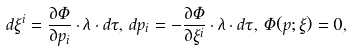<formula> <loc_0><loc_0><loc_500><loc_500>d \xi ^ { i } = \frac { \partial \Phi } { \partial p _ { i } } \cdot \lambda \cdot d \tau , \, d p _ { i } = - \frac { \partial \Phi } { \partial \xi ^ { i } } \cdot \lambda \cdot d \tau , \, \Phi ( p ; \xi ) = 0 ,</formula> 